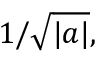<formula> <loc_0><loc_0><loc_500><loc_500>1 / { \sqrt { | a | } } ,</formula> 